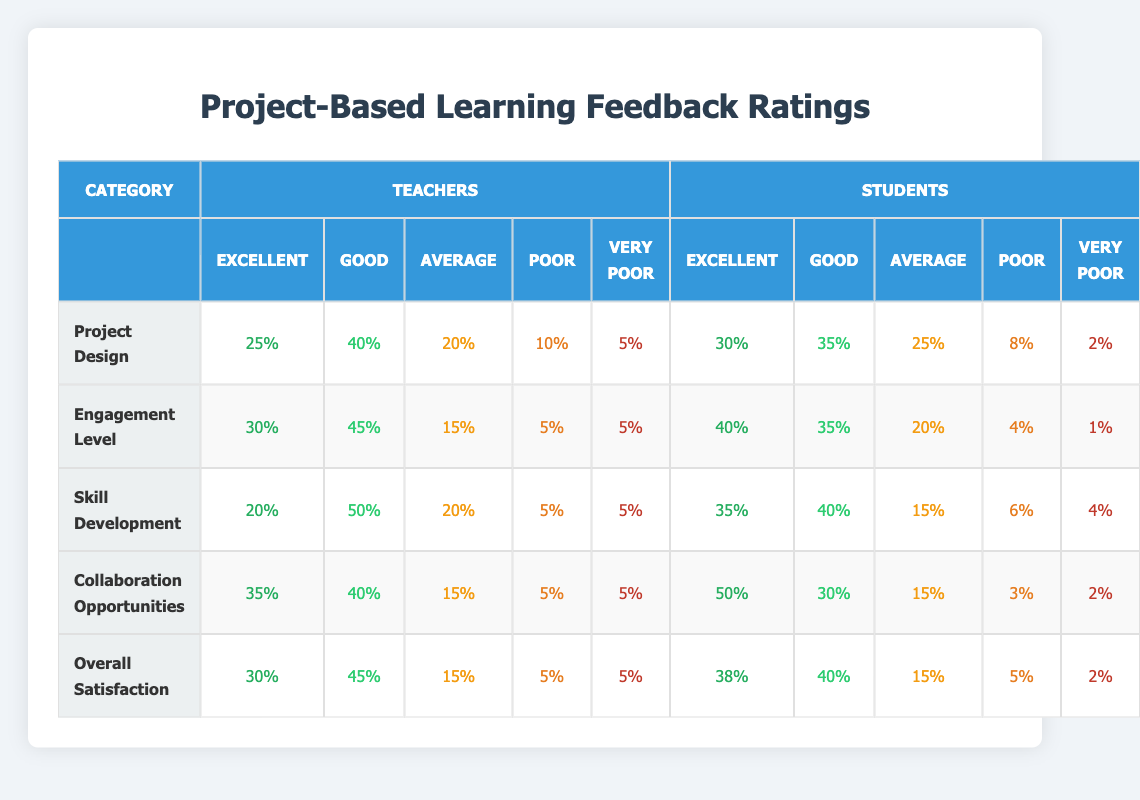What is the percentage of teachers who rated the Project Design as excellent? Looking at the "Project Design" row under the "Teachers" section, we find that 25% rated it as excellent.
Answer: 25% How many students rated the Collaboration Opportunities as poor? In the "Collaboration Opportunities" row under the "Students" section, the percentage for the poor rating is 3%.
Answer: 3% What is the total percentage of students who rated Engagement Level as either excellent or good? The percentages for excellent and good ratings are 40% and 35% respectively. Adding these percentages gives us 40% + 35% = 75%.
Answer: 75% Did more teachers rate Skill Development as good compared to students? For teachers, 50% rated it as good, while for students, 40% gave a good rating. Since 50% is greater than 40%, the statement is true.
Answer: Yes What is the percentage difference in excellent ratings for Overall Satisfaction between teachers and students? Teachers rated Overall Satisfaction as 30% excellent, while students rated it as 38%. The difference is 38% - 30% = 8%.
Answer: 8% Which category had the highest percentage of excellent ratings from students? Looking at the student ratings, "Collaboration Opportunities" has the highest percentage at 50% for excellent ratings.
Answer: Collaboration Opportunities What percentage of teachers rated Engagement Level as either average or poor? Teachers rated 15% as average and 5% as poor for Engagement Level. Adding these gives 15% + 5% = 20%.
Answer: 20% Is the percentage of teachers who rated Collaboration Opportunities as excellent greater than those who rated it as poor? Teachers rated 35% as excellent and 5% as poor for Collaboration Opportunities. Since 35% is greater than 5%, the answer is yes.
Answer: Yes What percentage of students rated Skill Development as average or very poor? For students, the average rating is 15% and the very poor rating is 4%. Adding these gives us 15% + 4% = 19%.
Answer: 19% 